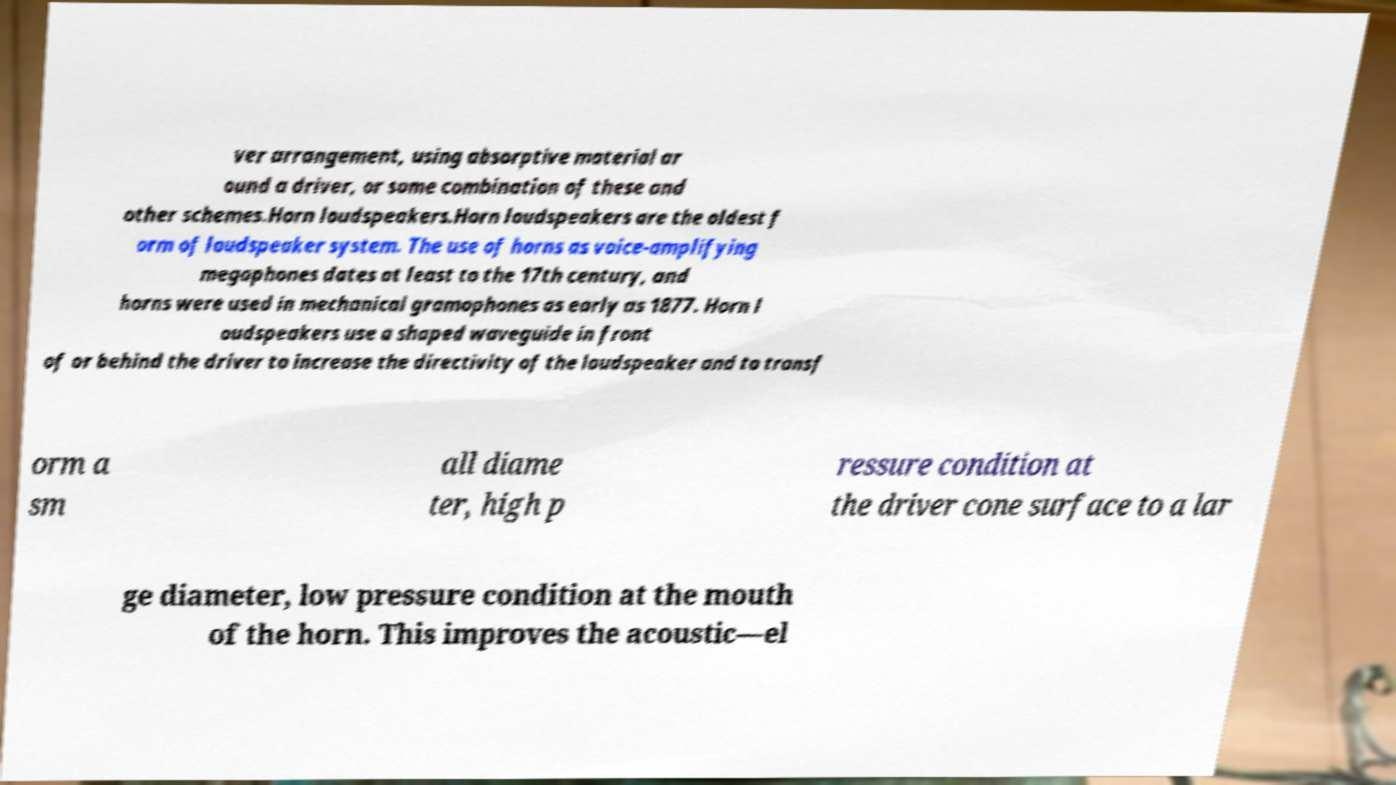Please read and relay the text visible in this image. What does it say? ver arrangement, using absorptive material ar ound a driver, or some combination of these and other schemes.Horn loudspeakers.Horn loudspeakers are the oldest f orm of loudspeaker system. The use of horns as voice-amplifying megaphones dates at least to the 17th century, and horns were used in mechanical gramophones as early as 1877. Horn l oudspeakers use a shaped waveguide in front of or behind the driver to increase the directivity of the loudspeaker and to transf orm a sm all diame ter, high p ressure condition at the driver cone surface to a lar ge diameter, low pressure condition at the mouth of the horn. This improves the acoustic—el 